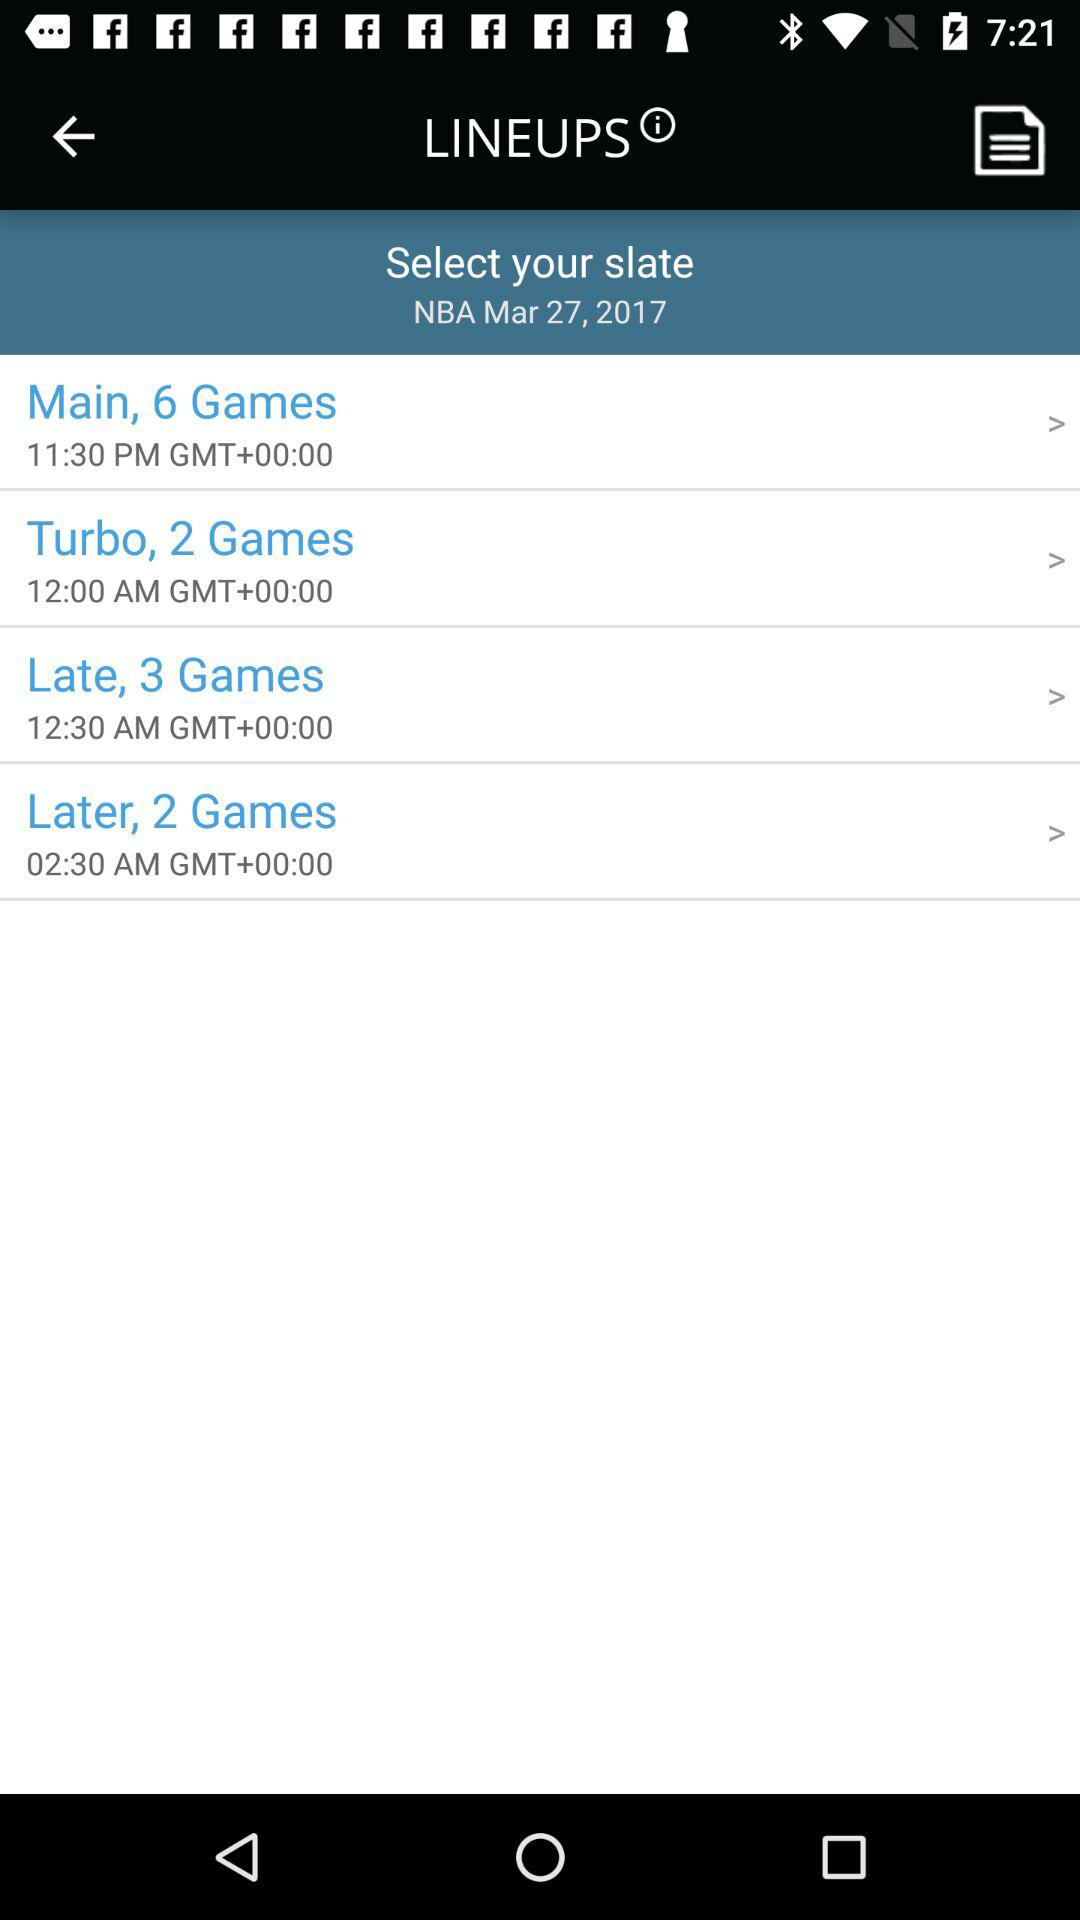What is the date? The date is March 27, 2017. 